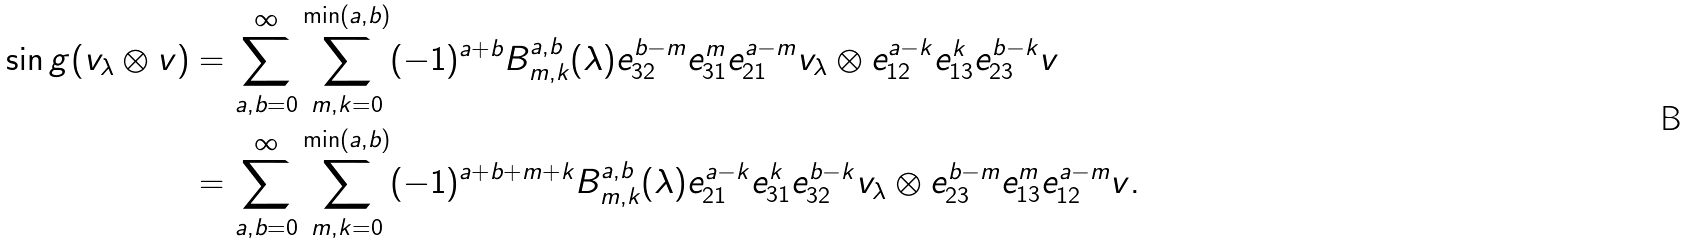<formula> <loc_0><loc_0><loc_500><loc_500>\sin g ( v _ { \lambda } \otimes v ) & = \sum _ { a , b = 0 } ^ { \infty } \sum _ { m , k = 0 } ^ { \min ( a , b ) } ( - 1 ) ^ { a + b } B _ { m , k } ^ { a , b } ( \lambda ) e _ { 3 2 } ^ { b - m } e _ { 3 1 } ^ { m } e _ { 2 1 } ^ { a - m } v _ { \lambda } \otimes e _ { 1 2 } ^ { a - k } e _ { 1 3 } ^ { k } e _ { 2 3 } ^ { b - k } v \\ & = \sum _ { a , b = 0 } ^ { \infty } \sum _ { m , k = 0 } ^ { \min ( a , b ) } ( - 1 ) ^ { a + b + m + k } B _ { m , k } ^ { a , b } ( \lambda ) e _ { 2 1 } ^ { a - k } e _ { 3 1 } ^ { k } e _ { 3 2 } ^ { b - k } v _ { \lambda } \otimes e _ { 2 3 } ^ { b - m } e _ { 1 3 } ^ { m } e _ { 1 2 } ^ { a - m } v .</formula> 